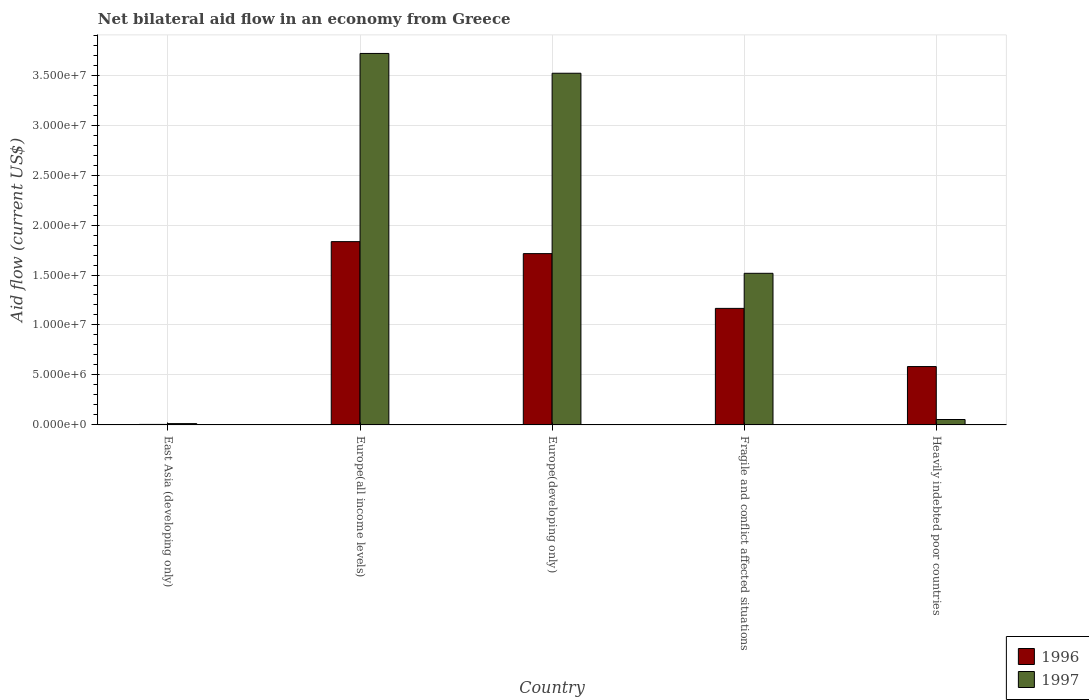How many different coloured bars are there?
Give a very brief answer. 2. Are the number of bars on each tick of the X-axis equal?
Offer a terse response. Yes. How many bars are there on the 4th tick from the right?
Make the answer very short. 2. What is the label of the 4th group of bars from the left?
Your answer should be compact. Fragile and conflict affected situations. What is the net bilateral aid flow in 1996 in Fragile and conflict affected situations?
Keep it short and to the point. 1.17e+07. Across all countries, what is the maximum net bilateral aid flow in 1996?
Provide a short and direct response. 1.83e+07. In which country was the net bilateral aid flow in 1996 maximum?
Offer a very short reply. Europe(all income levels). In which country was the net bilateral aid flow in 1997 minimum?
Your answer should be compact. East Asia (developing only). What is the total net bilateral aid flow in 1997 in the graph?
Ensure brevity in your answer.  8.82e+07. What is the difference between the net bilateral aid flow in 1996 in Europe(developing only) and that in Heavily indebted poor countries?
Your response must be concise. 1.13e+07. What is the difference between the net bilateral aid flow in 1997 in Heavily indebted poor countries and the net bilateral aid flow in 1996 in Europe(developing only)?
Ensure brevity in your answer.  -1.66e+07. What is the average net bilateral aid flow in 1997 per country?
Offer a very short reply. 1.76e+07. What is the difference between the net bilateral aid flow of/in 1997 and net bilateral aid flow of/in 1996 in Europe(all income levels)?
Your answer should be very brief. 1.88e+07. In how many countries, is the net bilateral aid flow in 1997 greater than 14000000 US$?
Offer a terse response. 3. What is the ratio of the net bilateral aid flow in 1996 in Europe(developing only) to that in Fragile and conflict affected situations?
Offer a terse response. 1.47. What is the difference between the highest and the second highest net bilateral aid flow in 1997?
Your answer should be very brief. 1.98e+06. What is the difference between the highest and the lowest net bilateral aid flow in 1996?
Provide a short and direct response. 1.83e+07. What does the 1st bar from the right in Fragile and conflict affected situations represents?
Keep it short and to the point. 1997. What is the difference between two consecutive major ticks on the Y-axis?
Your response must be concise. 5.00e+06. Are the values on the major ticks of Y-axis written in scientific E-notation?
Keep it short and to the point. Yes. Does the graph contain any zero values?
Offer a very short reply. No. How many legend labels are there?
Your response must be concise. 2. How are the legend labels stacked?
Your answer should be compact. Vertical. What is the title of the graph?
Your answer should be compact. Net bilateral aid flow in an economy from Greece. What is the label or title of the Y-axis?
Provide a succinct answer. Aid flow (current US$). What is the Aid flow (current US$) of 1997 in East Asia (developing only)?
Keep it short and to the point. 1.30e+05. What is the Aid flow (current US$) in 1996 in Europe(all income levels)?
Your answer should be very brief. 1.83e+07. What is the Aid flow (current US$) in 1997 in Europe(all income levels)?
Your response must be concise. 3.72e+07. What is the Aid flow (current US$) of 1996 in Europe(developing only)?
Your response must be concise. 1.71e+07. What is the Aid flow (current US$) of 1997 in Europe(developing only)?
Your answer should be very brief. 3.52e+07. What is the Aid flow (current US$) in 1996 in Fragile and conflict affected situations?
Your answer should be compact. 1.17e+07. What is the Aid flow (current US$) in 1997 in Fragile and conflict affected situations?
Your answer should be compact. 1.52e+07. What is the Aid flow (current US$) of 1996 in Heavily indebted poor countries?
Provide a succinct answer. 5.84e+06. What is the Aid flow (current US$) of 1997 in Heavily indebted poor countries?
Ensure brevity in your answer.  5.40e+05. Across all countries, what is the maximum Aid flow (current US$) in 1996?
Make the answer very short. 1.83e+07. Across all countries, what is the maximum Aid flow (current US$) of 1997?
Keep it short and to the point. 3.72e+07. Across all countries, what is the minimum Aid flow (current US$) in 1996?
Your answer should be compact. 5.00e+04. What is the total Aid flow (current US$) in 1996 in the graph?
Your answer should be very brief. 5.30e+07. What is the total Aid flow (current US$) in 1997 in the graph?
Your answer should be very brief. 8.82e+07. What is the difference between the Aid flow (current US$) in 1996 in East Asia (developing only) and that in Europe(all income levels)?
Your answer should be very brief. -1.83e+07. What is the difference between the Aid flow (current US$) in 1997 in East Asia (developing only) and that in Europe(all income levels)?
Provide a succinct answer. -3.70e+07. What is the difference between the Aid flow (current US$) in 1996 in East Asia (developing only) and that in Europe(developing only)?
Keep it short and to the point. -1.71e+07. What is the difference between the Aid flow (current US$) of 1997 in East Asia (developing only) and that in Europe(developing only)?
Your response must be concise. -3.51e+07. What is the difference between the Aid flow (current US$) in 1996 in East Asia (developing only) and that in Fragile and conflict affected situations?
Give a very brief answer. -1.16e+07. What is the difference between the Aid flow (current US$) of 1997 in East Asia (developing only) and that in Fragile and conflict affected situations?
Your answer should be compact. -1.50e+07. What is the difference between the Aid flow (current US$) in 1996 in East Asia (developing only) and that in Heavily indebted poor countries?
Provide a short and direct response. -5.79e+06. What is the difference between the Aid flow (current US$) of 1997 in East Asia (developing only) and that in Heavily indebted poor countries?
Give a very brief answer. -4.10e+05. What is the difference between the Aid flow (current US$) in 1996 in Europe(all income levels) and that in Europe(developing only)?
Offer a very short reply. 1.20e+06. What is the difference between the Aid flow (current US$) in 1997 in Europe(all income levels) and that in Europe(developing only)?
Give a very brief answer. 1.98e+06. What is the difference between the Aid flow (current US$) in 1996 in Europe(all income levels) and that in Fragile and conflict affected situations?
Make the answer very short. 6.68e+06. What is the difference between the Aid flow (current US$) of 1997 in Europe(all income levels) and that in Fragile and conflict affected situations?
Your response must be concise. 2.20e+07. What is the difference between the Aid flow (current US$) of 1996 in Europe(all income levels) and that in Heavily indebted poor countries?
Your response must be concise. 1.25e+07. What is the difference between the Aid flow (current US$) of 1997 in Europe(all income levels) and that in Heavily indebted poor countries?
Ensure brevity in your answer.  3.66e+07. What is the difference between the Aid flow (current US$) in 1996 in Europe(developing only) and that in Fragile and conflict affected situations?
Give a very brief answer. 5.48e+06. What is the difference between the Aid flow (current US$) in 1997 in Europe(developing only) and that in Fragile and conflict affected situations?
Offer a very short reply. 2.00e+07. What is the difference between the Aid flow (current US$) in 1996 in Europe(developing only) and that in Heavily indebted poor countries?
Provide a short and direct response. 1.13e+07. What is the difference between the Aid flow (current US$) of 1997 in Europe(developing only) and that in Heavily indebted poor countries?
Provide a succinct answer. 3.46e+07. What is the difference between the Aid flow (current US$) of 1996 in Fragile and conflict affected situations and that in Heavily indebted poor countries?
Make the answer very short. 5.82e+06. What is the difference between the Aid flow (current US$) of 1997 in Fragile and conflict affected situations and that in Heavily indebted poor countries?
Your answer should be very brief. 1.46e+07. What is the difference between the Aid flow (current US$) of 1996 in East Asia (developing only) and the Aid flow (current US$) of 1997 in Europe(all income levels)?
Your answer should be compact. -3.71e+07. What is the difference between the Aid flow (current US$) of 1996 in East Asia (developing only) and the Aid flow (current US$) of 1997 in Europe(developing only)?
Your answer should be compact. -3.51e+07. What is the difference between the Aid flow (current US$) of 1996 in East Asia (developing only) and the Aid flow (current US$) of 1997 in Fragile and conflict affected situations?
Give a very brief answer. -1.51e+07. What is the difference between the Aid flow (current US$) of 1996 in East Asia (developing only) and the Aid flow (current US$) of 1997 in Heavily indebted poor countries?
Give a very brief answer. -4.90e+05. What is the difference between the Aid flow (current US$) of 1996 in Europe(all income levels) and the Aid flow (current US$) of 1997 in Europe(developing only)?
Give a very brief answer. -1.68e+07. What is the difference between the Aid flow (current US$) in 1996 in Europe(all income levels) and the Aid flow (current US$) in 1997 in Fragile and conflict affected situations?
Your response must be concise. 3.17e+06. What is the difference between the Aid flow (current US$) of 1996 in Europe(all income levels) and the Aid flow (current US$) of 1997 in Heavily indebted poor countries?
Ensure brevity in your answer.  1.78e+07. What is the difference between the Aid flow (current US$) of 1996 in Europe(developing only) and the Aid flow (current US$) of 1997 in Fragile and conflict affected situations?
Your answer should be compact. 1.97e+06. What is the difference between the Aid flow (current US$) in 1996 in Europe(developing only) and the Aid flow (current US$) in 1997 in Heavily indebted poor countries?
Offer a very short reply. 1.66e+07. What is the difference between the Aid flow (current US$) of 1996 in Fragile and conflict affected situations and the Aid flow (current US$) of 1997 in Heavily indebted poor countries?
Offer a very short reply. 1.11e+07. What is the average Aid flow (current US$) in 1996 per country?
Your answer should be very brief. 1.06e+07. What is the average Aid flow (current US$) in 1997 per country?
Offer a terse response. 1.76e+07. What is the difference between the Aid flow (current US$) of 1996 and Aid flow (current US$) of 1997 in East Asia (developing only)?
Give a very brief answer. -8.00e+04. What is the difference between the Aid flow (current US$) of 1996 and Aid flow (current US$) of 1997 in Europe(all income levels)?
Your answer should be very brief. -1.88e+07. What is the difference between the Aid flow (current US$) in 1996 and Aid flow (current US$) in 1997 in Europe(developing only)?
Provide a succinct answer. -1.80e+07. What is the difference between the Aid flow (current US$) of 1996 and Aid flow (current US$) of 1997 in Fragile and conflict affected situations?
Ensure brevity in your answer.  -3.51e+06. What is the difference between the Aid flow (current US$) in 1996 and Aid flow (current US$) in 1997 in Heavily indebted poor countries?
Offer a terse response. 5.30e+06. What is the ratio of the Aid flow (current US$) in 1996 in East Asia (developing only) to that in Europe(all income levels)?
Make the answer very short. 0. What is the ratio of the Aid flow (current US$) of 1997 in East Asia (developing only) to that in Europe(all income levels)?
Offer a terse response. 0. What is the ratio of the Aid flow (current US$) in 1996 in East Asia (developing only) to that in Europe(developing only)?
Your answer should be compact. 0. What is the ratio of the Aid flow (current US$) of 1997 in East Asia (developing only) to that in Europe(developing only)?
Ensure brevity in your answer.  0. What is the ratio of the Aid flow (current US$) in 1996 in East Asia (developing only) to that in Fragile and conflict affected situations?
Your answer should be compact. 0. What is the ratio of the Aid flow (current US$) in 1997 in East Asia (developing only) to that in Fragile and conflict affected situations?
Provide a short and direct response. 0.01. What is the ratio of the Aid flow (current US$) in 1996 in East Asia (developing only) to that in Heavily indebted poor countries?
Your response must be concise. 0.01. What is the ratio of the Aid flow (current US$) of 1997 in East Asia (developing only) to that in Heavily indebted poor countries?
Your response must be concise. 0.24. What is the ratio of the Aid flow (current US$) in 1996 in Europe(all income levels) to that in Europe(developing only)?
Your response must be concise. 1.07. What is the ratio of the Aid flow (current US$) in 1997 in Europe(all income levels) to that in Europe(developing only)?
Your answer should be very brief. 1.06. What is the ratio of the Aid flow (current US$) in 1996 in Europe(all income levels) to that in Fragile and conflict affected situations?
Give a very brief answer. 1.57. What is the ratio of the Aid flow (current US$) in 1997 in Europe(all income levels) to that in Fragile and conflict affected situations?
Provide a short and direct response. 2.45. What is the ratio of the Aid flow (current US$) of 1996 in Europe(all income levels) to that in Heavily indebted poor countries?
Offer a very short reply. 3.14. What is the ratio of the Aid flow (current US$) in 1997 in Europe(all income levels) to that in Heavily indebted poor countries?
Offer a terse response. 68.83. What is the ratio of the Aid flow (current US$) of 1996 in Europe(developing only) to that in Fragile and conflict affected situations?
Keep it short and to the point. 1.47. What is the ratio of the Aid flow (current US$) in 1997 in Europe(developing only) to that in Fragile and conflict affected situations?
Keep it short and to the point. 2.32. What is the ratio of the Aid flow (current US$) in 1996 in Europe(developing only) to that in Heavily indebted poor countries?
Offer a very short reply. 2.93. What is the ratio of the Aid flow (current US$) of 1997 in Europe(developing only) to that in Heavily indebted poor countries?
Offer a terse response. 65.17. What is the ratio of the Aid flow (current US$) in 1996 in Fragile and conflict affected situations to that in Heavily indebted poor countries?
Your response must be concise. 2. What is the ratio of the Aid flow (current US$) of 1997 in Fragile and conflict affected situations to that in Heavily indebted poor countries?
Your answer should be compact. 28.09. What is the difference between the highest and the second highest Aid flow (current US$) of 1996?
Give a very brief answer. 1.20e+06. What is the difference between the highest and the second highest Aid flow (current US$) of 1997?
Offer a very short reply. 1.98e+06. What is the difference between the highest and the lowest Aid flow (current US$) in 1996?
Make the answer very short. 1.83e+07. What is the difference between the highest and the lowest Aid flow (current US$) in 1997?
Your answer should be very brief. 3.70e+07. 